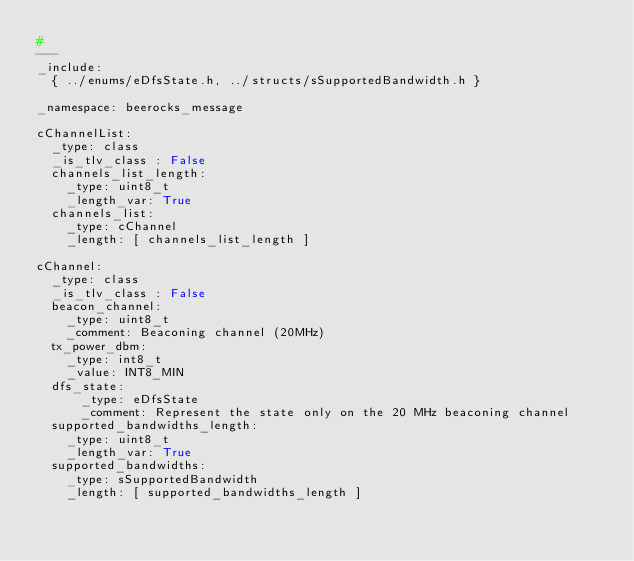Convert code to text. <code><loc_0><loc_0><loc_500><loc_500><_YAML_>#
---
_include:
  { ../enums/eDfsState.h, ../structs/sSupportedBandwidth.h }

_namespace: beerocks_message

cChannelList:
  _type: class
  _is_tlv_class : False
  channels_list_length:
    _type: uint8_t
    _length_var: True
  channels_list:
    _type: cChannel
    _length: [ channels_list_length ]

cChannel:
  _type: class
  _is_tlv_class : False
  beacon_channel:
    _type: uint8_t
    _comment: Beaconing channel (20MHz)
  tx_power_dbm:
    _type: int8_t
    _value: INT8_MIN
  dfs_state: 
      _type: eDfsState
      _comment: Represent the state only on the 20 MHz beaconing channel
  supported_bandwidths_length:
    _type: uint8_t
    _length_var: True
  supported_bandwidths:
    _type: sSupportedBandwidth
    _length: [ supported_bandwidths_length ]
</code> 